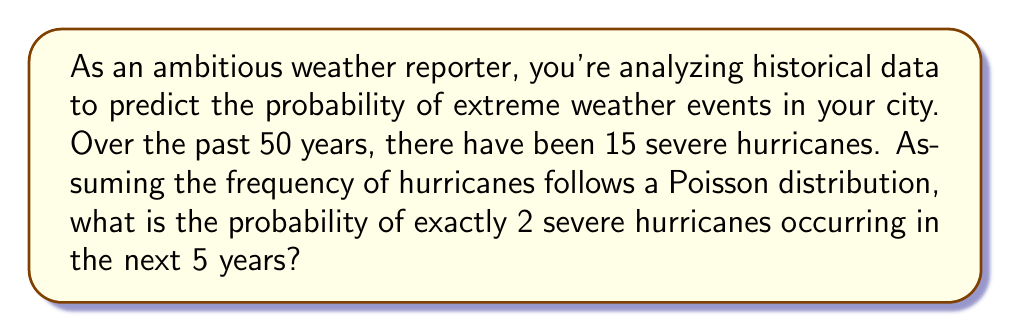Help me with this question. To solve this problem, we'll use the Poisson distribution formula:

$$P(X = k) = \frac{e^{-\lambda} \lambda^k}{k!}$$

Where:
$P(X = k)$ is the probability of exactly $k$ events occurring
$\lambda$ is the average rate of events per time period
$e$ is Euler's number (approximately 2.71828)
$k$ is the number of events we're calculating the probability for

Step 1: Calculate $\lambda$ (average rate of hurricanes per 5-year period)
- In 50 years, there were 15 hurricanes
- In 5 years (our time frame), we expect: $\lambda = 15 \times (5/50) = 1.5$

Step 2: Use the Poisson distribution formula with $k = 2$ and $\lambda = 1.5$

$$P(X = 2) = \frac{e^{-1.5} 1.5^2}{2!}$$

Step 3: Calculate each part:
- $e^{-1.5} \approx 0.22313$
- $1.5^2 = 2.25$
- $2! = 2$

Step 4: Put it all together:

$$P(X = 2) = \frac{0.22313 \times 2.25}{2} \approx 0.25102$$

Step 5: Convert to a percentage:
$0.25102 \times 100\% \approx 25.10\%$
Answer: The probability of exactly 2 severe hurricanes occurring in the next 5 years is approximately 25.10%. 